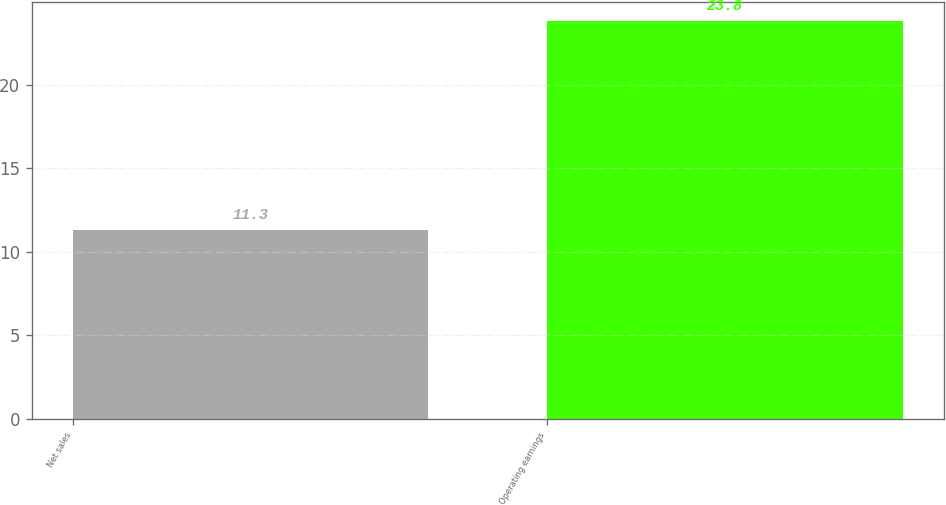Convert chart to OTSL. <chart><loc_0><loc_0><loc_500><loc_500><bar_chart><fcel>Net sales<fcel>Operating earnings<nl><fcel>11.3<fcel>23.8<nl></chart> 